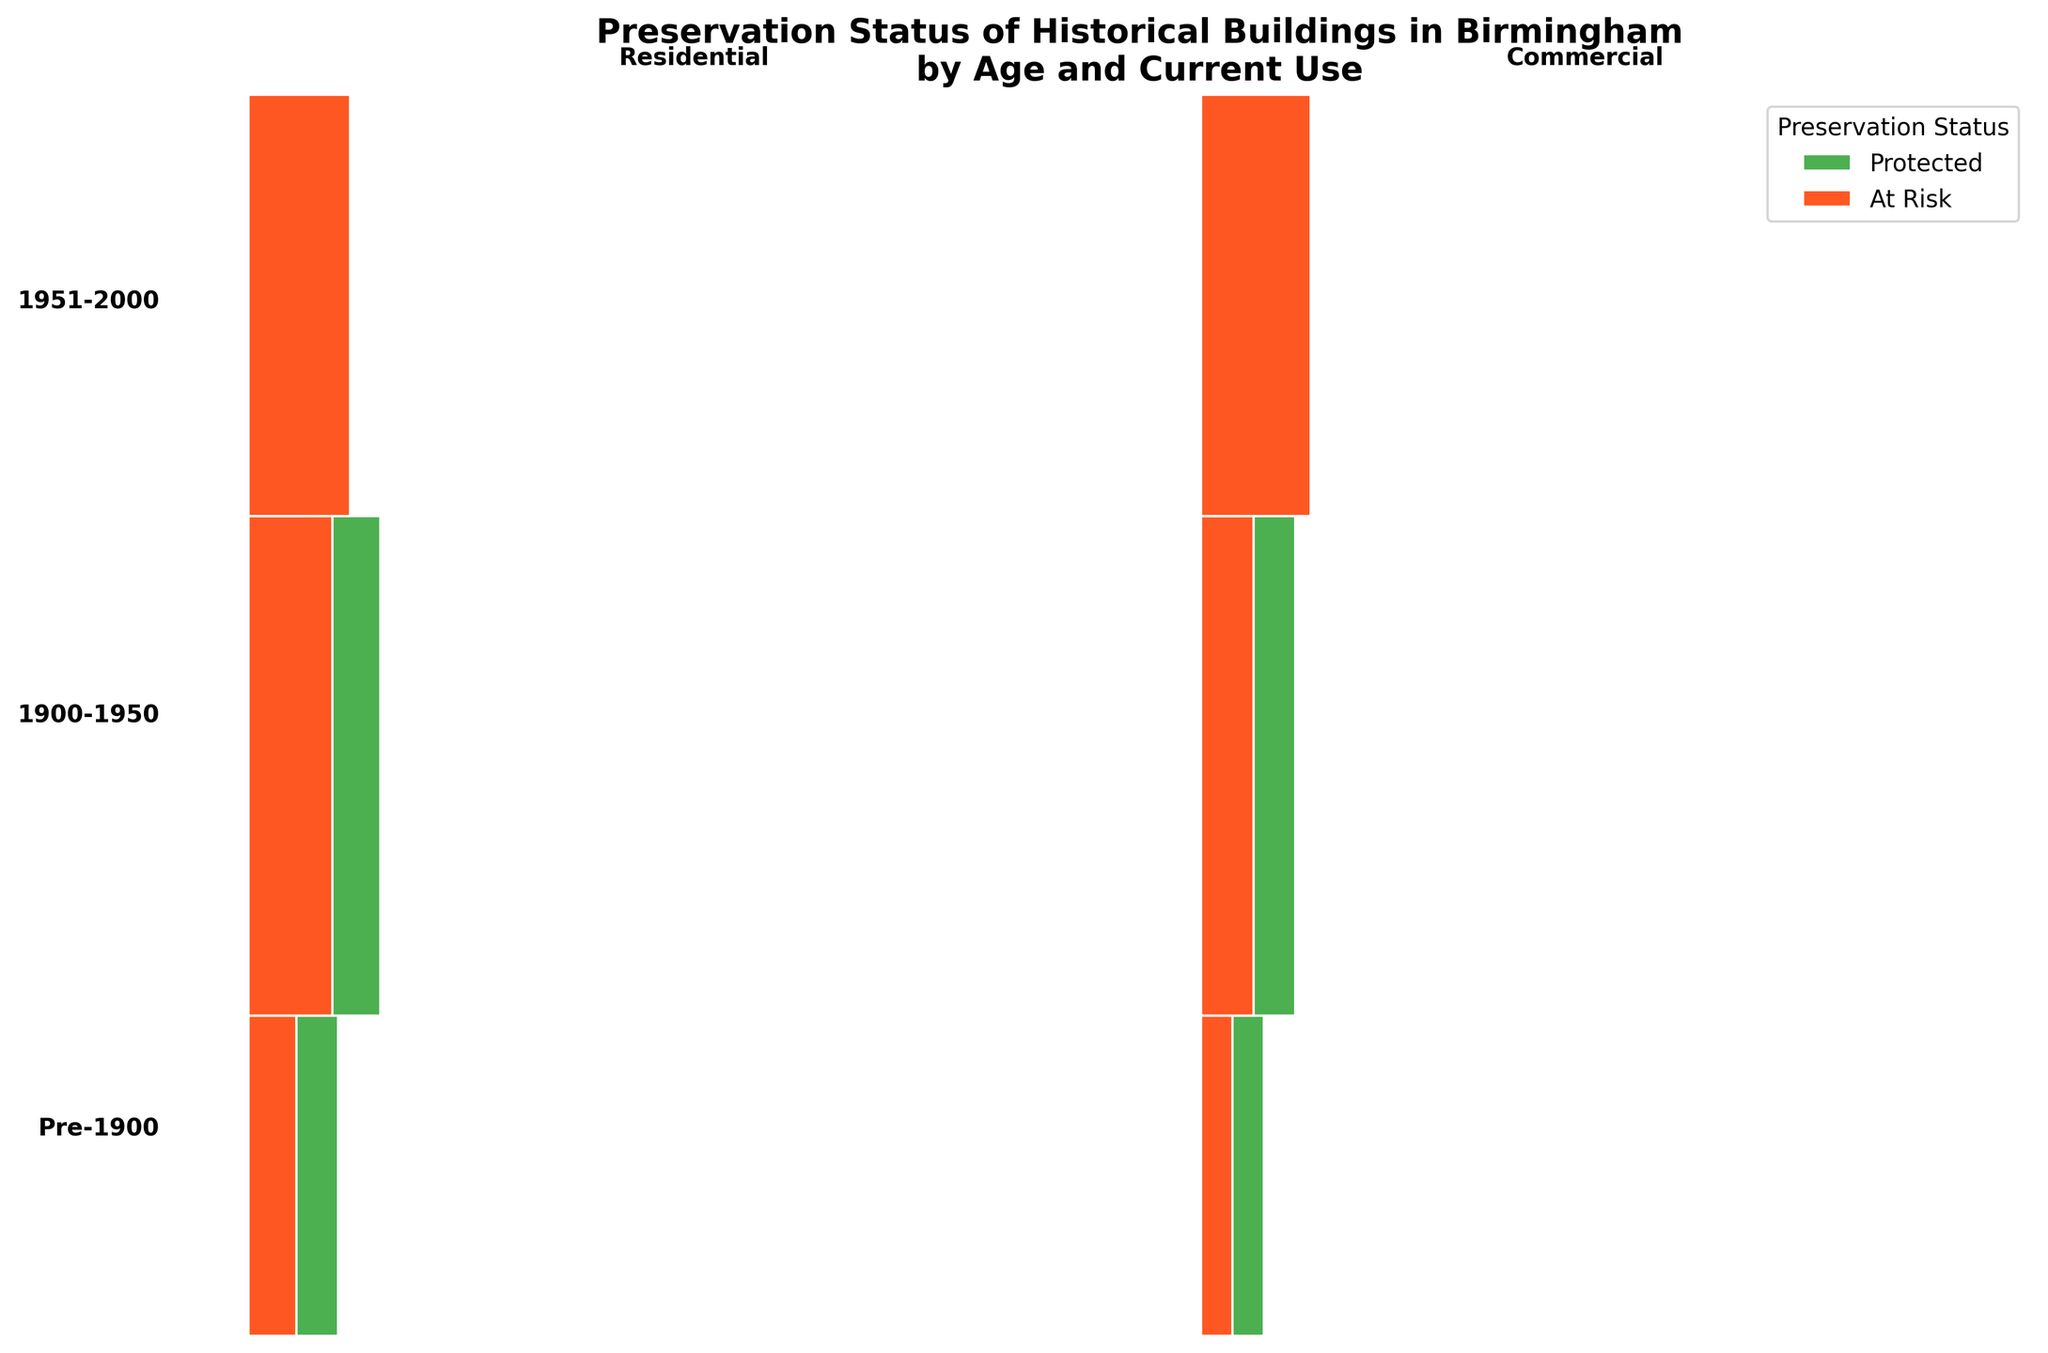What is the title of the plot? The title of the plot is usually located at the top of the figure. Here, it states, "Preservation Status of Historical Buildings in Birmingham by Age and Current Use".
Answer: Preservation Status of Historical Buildings in Birmingham by Age and Current Use What are the colors representing the Preservation Status categories? The colors representing the Preservation Status categories can be inferred from the legend on the plot. Protected is shown in a green color, and At Risk is shown in a reddish-orange color.
Answer: Green for Protected, Reddish-Orange for At Risk Which age category has the highest number of buildings at risk? To find the age category with the highest number of buildings at risk, look at the proportion of the reddish-orange sections within each age category. The largest reddish-orange section is for the 1951-2000 age category.
Answer: 1951-2000 What is the difference in the number of protected residential buildings between Pre-1900 and 1900-1950 age categories? For Pre-1900 residential buildings, the number of protected buildings is represented by the green section, which is 15. For 1900-1950 residential, it is 22. The difference is 22 - 15.
Answer: 7 In which age category and current use is the proportion of Protected buildings the highest? Examine each age and current use combination for the length of the green sections relative to the total width. The highest proportion of Protected buildings is in the 1900-1950 Residential category.
Answer: 1900-1950 Residential How many more commercial buildings are at risk compared to residential buildings in the 1951-2000 age category? For 1951-2000 age category, Commercial buildings at risk are 21, and Residential buildings at risk are 17. The difference is 21 - 17.
Answer: 4 Comparing the Commercial use for all age categories, which age category has the fewest protected buildings? Reviewing the green sections in the Commercial category for each age group, the 1951-2000 category has the fewest protected buildings.
Answer: 1951-2000 What is the sum of all protected buildings across all age categories and current uses? Sum the green sections for all combinations: 15 (Pre-1900 Residential) + 12 (Pre-1900 Commercial) + 22 (1900-1950 Residential) + 18 (1900-1950 Commercial) + 9 (1951-2000 Residential) + 7 (1951-2000 Commercial) = 83.
Answer: 83 Which current use, Residential or Commercial, has more buildings at risk in the 1900-1950 age category? In the 1900-1950 age category, Residential buildings at risk are 14, while Commercial buildings at risk are 10. Residential has more at-risk buildings.
Answer: Residential 